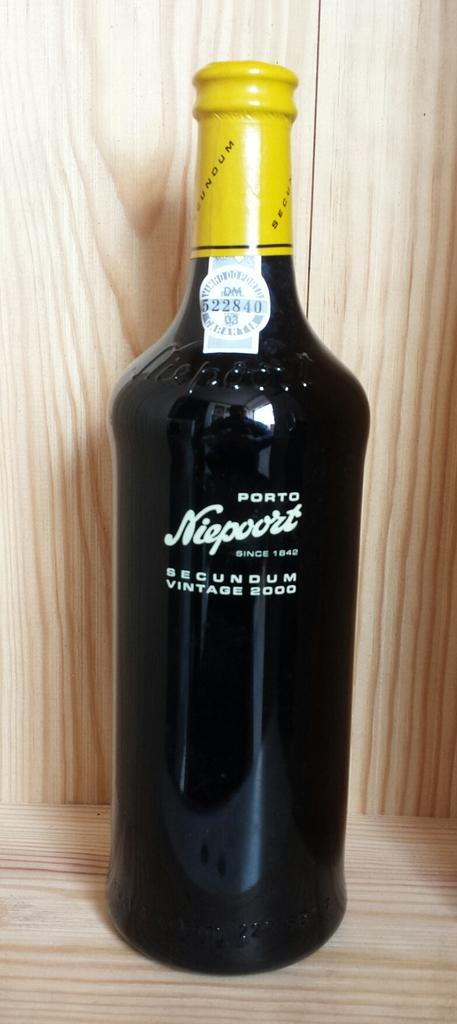<image>
Relay a brief, clear account of the picture shown. A bottle of port with the lable Niepoort on written on it. 